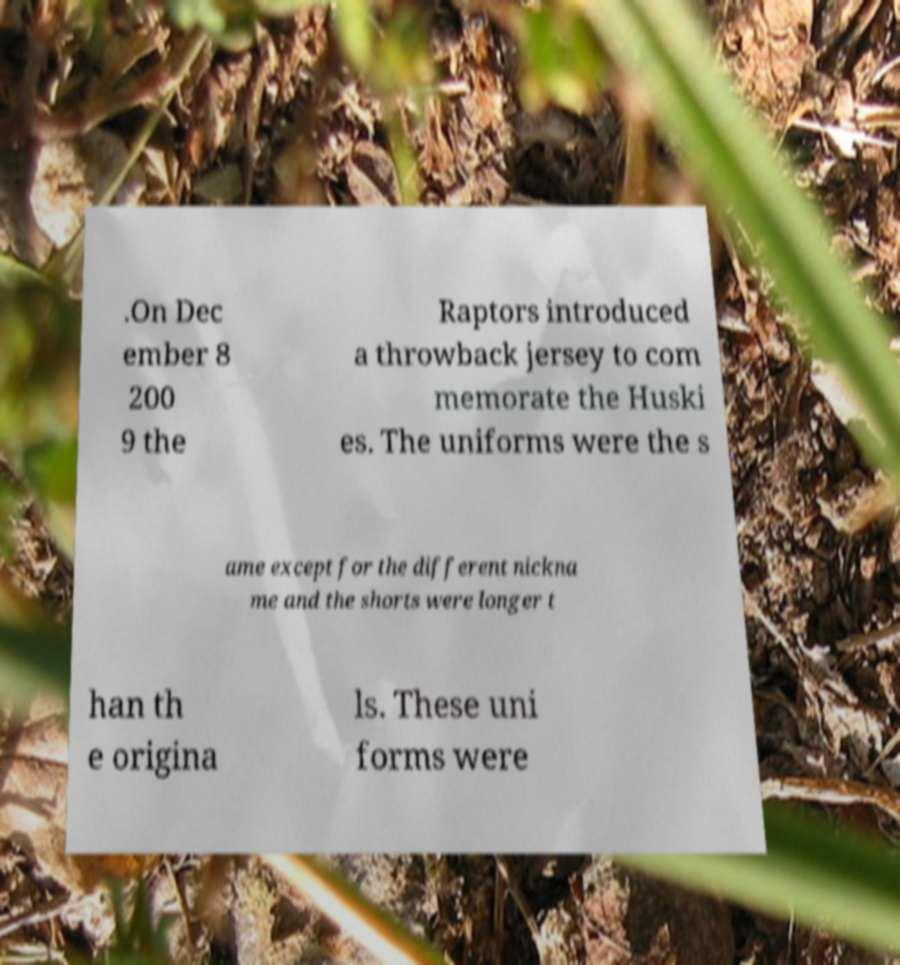Can you read and provide the text displayed in the image?This photo seems to have some interesting text. Can you extract and type it out for me? .On Dec ember 8 200 9 the Raptors introduced a throwback jersey to com memorate the Huski es. The uniforms were the s ame except for the different nickna me and the shorts were longer t han th e origina ls. These uni forms were 